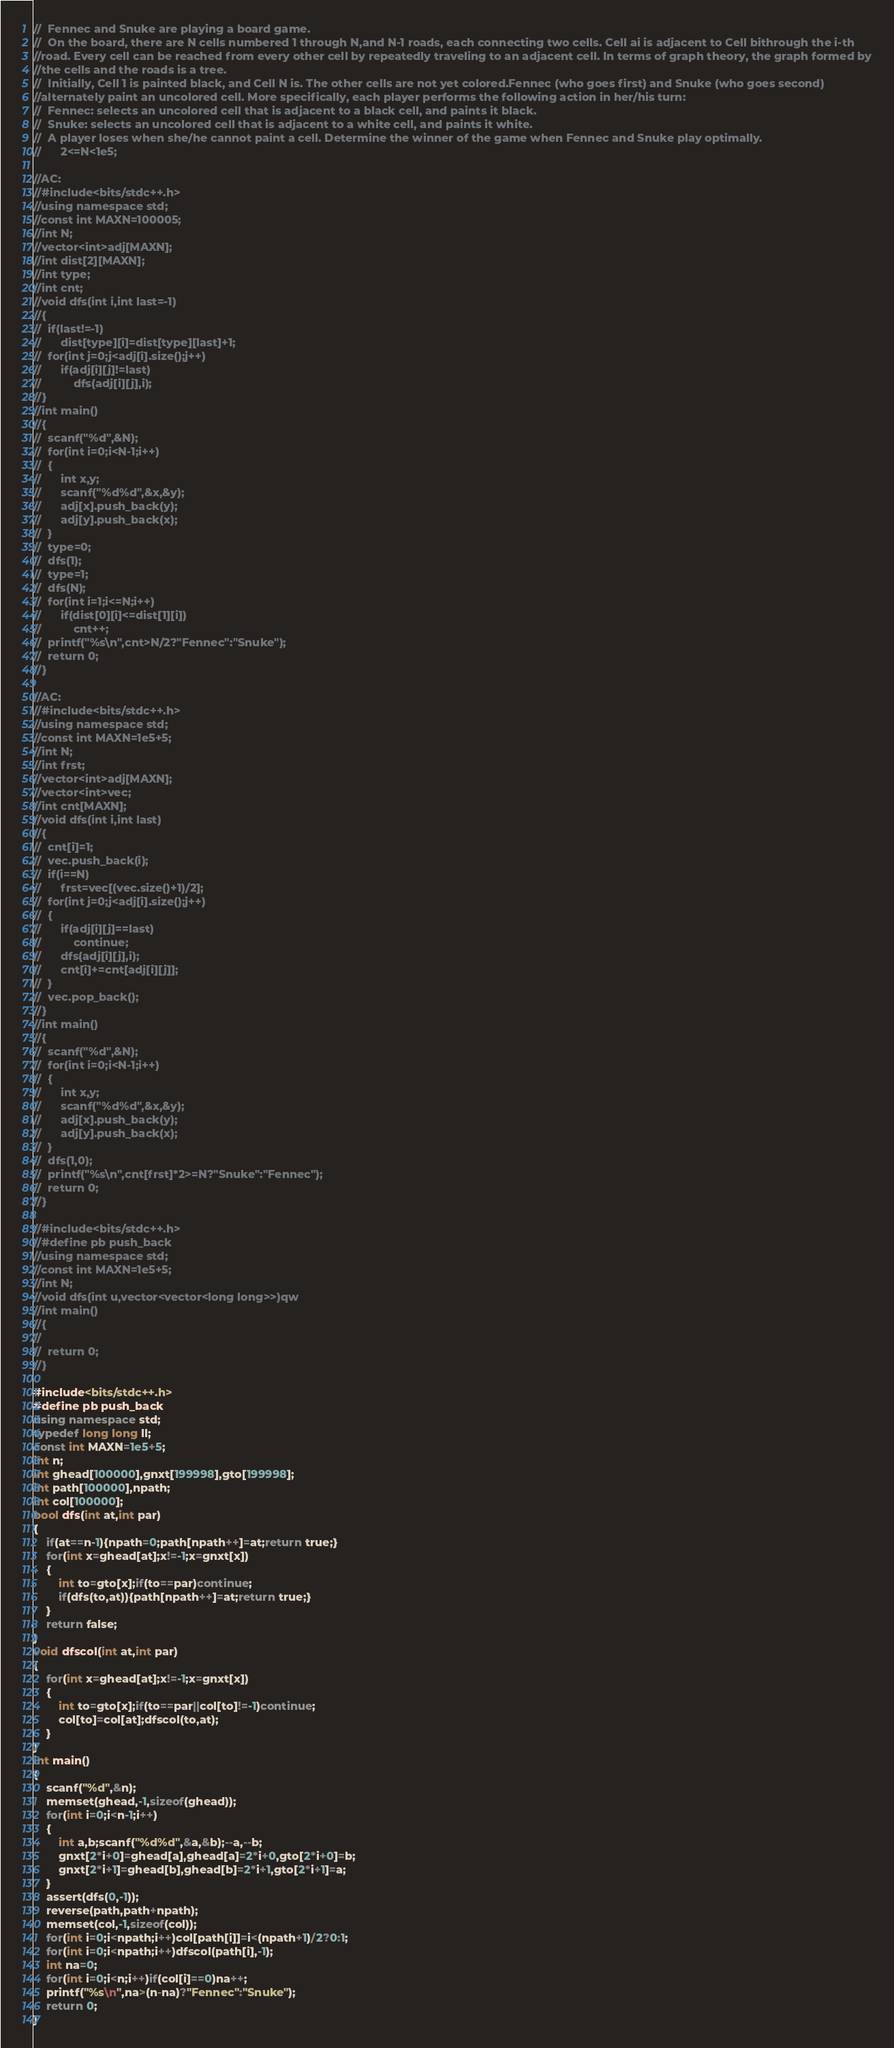<code> <loc_0><loc_0><loc_500><loc_500><_C++_>//	Fennec and Snuke are playing a board game.
//	On the board, there are N cells numbered 1 through N,and N-1 roads, each connecting two cells. Cell ai is adjacent to Cell bithrough the i-th 
//road. Every cell can be reached from every other cell by repeatedly traveling to an adjacent cell. In terms of graph theory, the graph formed by
//the cells and the roads is a tree.
//	Initially, Cell 1 is painted black, and Cell N is. The other cells are not yet colored.Fennec (who goes first) and Snuke (who goes second) 
//alternately paint an uncolored cell. More specifically, each player performs the following action in her/his turn:
//	Fennec: selects an uncolored cell that is adjacent to a black cell, and paints it black.
//	Snuke: selects an uncolored cell that is adjacent to a white cell, and paints it white.
//	A player loses when she/he cannot paint a cell. Determine the winner of the game when Fennec and Snuke play optimally.
//		2<=N<1e5;

//AC:
//#include<bits/stdc++.h>
//using namespace std;
//const int MAXN=100005;
//int N;
//vector<int>adj[MAXN];
//int dist[2][MAXN];
//int type;
//int cnt;
//void dfs(int i,int last=-1)
//{
//	if(last!=-1)
//		dist[type][i]=dist[type][last]+1;
//	for(int j=0;j<adj[i].size();j++)
//		if(adj[i][j]!=last)
//			dfs(adj[i][j],i);
//}
//int main()
//{
//	scanf("%d",&N);
//	for(int i=0;i<N-1;i++)
//	{
//		int x,y;
//		scanf("%d%d",&x,&y);
//		adj[x].push_back(y);
//		adj[y].push_back(x);
//	}
//	type=0;
//	dfs(1);
//	type=1;
//	dfs(N);
//	for(int i=1;i<=N;i++)
//		if(dist[0][i]<=dist[1][i])
//			cnt++;
//	printf("%s\n",cnt>N/2?"Fennec":"Snuke");
//	return 0;
//}

//AC:
//#include<bits/stdc++.h>
//using namespace std;
//const int MAXN=1e5+5;
//int N;
//int frst;
//vector<int>adj[MAXN];
//vector<int>vec;
//int cnt[MAXN];
//void dfs(int i,int last)
//{
//	cnt[i]=1;
//	vec.push_back(i);
//	if(i==N)
//		frst=vec[(vec.size()+1)/2];
//	for(int j=0;j<adj[i].size();j++)
//	{
//		if(adj[i][j]==last)
//			continue;
//		dfs(adj[i][j],i);
//		cnt[i]+=cnt[adj[i][j]];
//	}
//	vec.pop_back();
//}
//int main()
//{
//	scanf("%d",&N);
//	for(int i=0;i<N-1;i++)
//	{
//		int x,y;
//		scanf("%d%d",&x,&y);
//		adj[x].push_back(y);
//		adj[y].push_back(x);
//	}
//	dfs(1,0);
//	printf("%s\n",cnt[frst]*2>=N?"Snuke":"Fennec");
//	return 0;
//}

//#include<bits/stdc++.h>
//#define pb push_back
//using namespace std;
//const int MAXN=1e5+5;
//int N;
//void dfs(int u,vector<vector<long long>>)qw
//int main()
//{
//	
//	return 0;
//}

#include<bits/stdc++.h>
#define pb push_back
using namespace std;
typedef long long ll;
const int MAXN=1e5+5;
int n;
int ghead[100000],gnxt[199998],gto[199998];
int path[100000],npath;
int col[100000];
bool dfs(int at,int par)
{
	if(at==n-1){npath=0;path[npath++]=at;return true;}
	for(int x=ghead[at];x!=-1;x=gnxt[x])
	{
		int to=gto[x];if(to==par)continue;
		if(dfs(to,at)){path[npath++]=at;return true;}
	}
	return false;
}
void dfscol(int at,int par)
{
	for(int x=ghead[at];x!=-1;x=gnxt[x])
	{
		int to=gto[x];if(to==par||col[to]!=-1)continue;
		col[to]=col[at];dfscol(to,at);
	}
}
int main()
{
	scanf("%d",&n);
	memset(ghead,-1,sizeof(ghead));
	for(int i=0;i<n-1;i++)
	{
		int a,b;scanf("%d%d",&a,&b);--a,--b;
		gnxt[2*i+0]=ghead[a],ghead[a]=2*i+0,gto[2*i+0]=b;
		gnxt[2*i+1]=ghead[b],ghead[b]=2*i+1,gto[2*i+1]=a;
	}
	assert(dfs(0,-1));
	reverse(path,path+npath);
	memset(col,-1,sizeof(col));
	for(int i=0;i<npath;i++)col[path[i]]=i<(npath+1)/2?0:1;
	for(int i=0;i<npath;i++)dfscol(path[i],-1);
	int na=0;
	for(int i=0;i<n;i++)if(col[i]==0)na++;
	printf("%s\n",na>(n-na)?"Fennec":"Snuke");
	return 0;
}</code> 